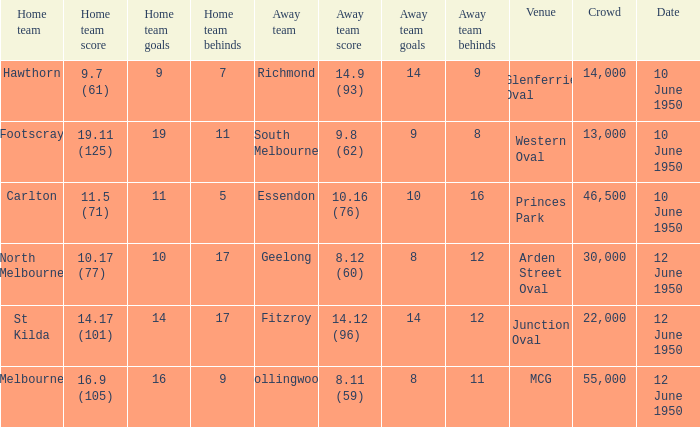What was the crowd when Melbourne was the home team? 55000.0. 